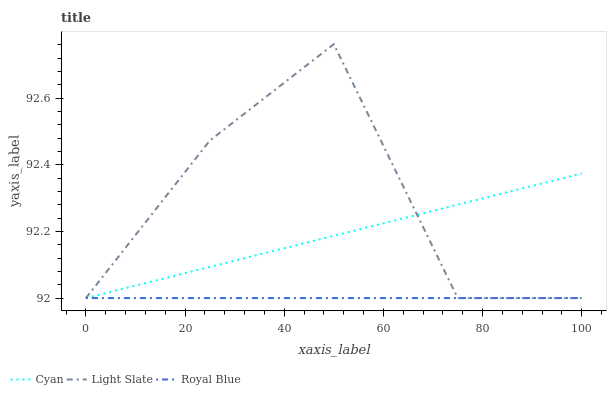Does Royal Blue have the minimum area under the curve?
Answer yes or no. Yes. Does Light Slate have the maximum area under the curve?
Answer yes or no. Yes. Does Cyan have the minimum area under the curve?
Answer yes or no. No. Does Cyan have the maximum area under the curve?
Answer yes or no. No. Is Royal Blue the smoothest?
Answer yes or no. Yes. Is Light Slate the roughest?
Answer yes or no. Yes. Is Cyan the smoothest?
Answer yes or no. No. Is Cyan the roughest?
Answer yes or no. No. Does Cyan have the highest value?
Answer yes or no. No. 